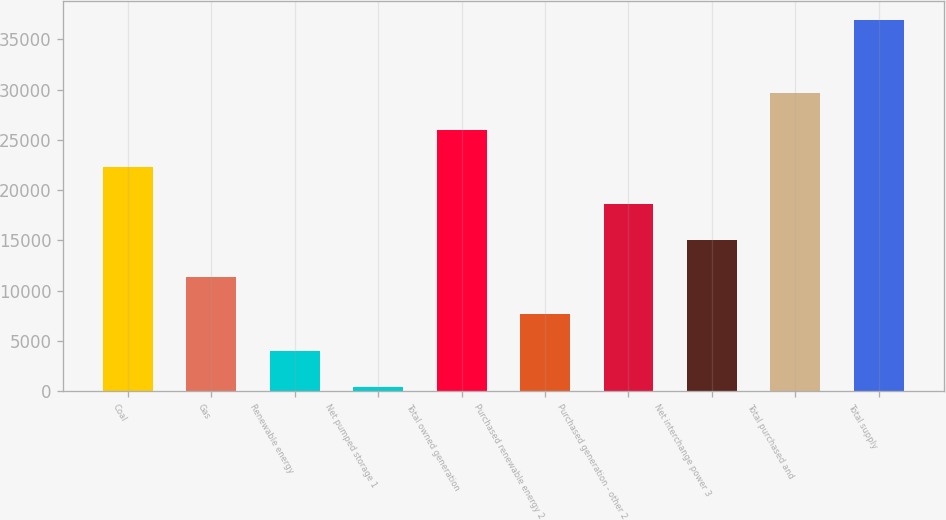<chart> <loc_0><loc_0><loc_500><loc_500><bar_chart><fcel>Coal<fcel>Gas<fcel>Renewable energy<fcel>Net pumped storage 1<fcel>Total owned generation<fcel>Purchased renewable energy 2<fcel>Purchased generation - other 2<fcel>Net interchange power 3<fcel>Total purchased and<fcel>Total supply<nl><fcel>22313.6<fcel>11339.3<fcel>4023.1<fcel>365<fcel>25971.7<fcel>7681.2<fcel>18655.5<fcel>14997.4<fcel>29629.8<fcel>36946<nl></chart> 